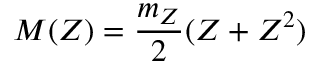<formula> <loc_0><loc_0><loc_500><loc_500>M ( Z ) = \frac { m _ { Z } } { 2 } ( Z + Z ^ { 2 } )</formula> 